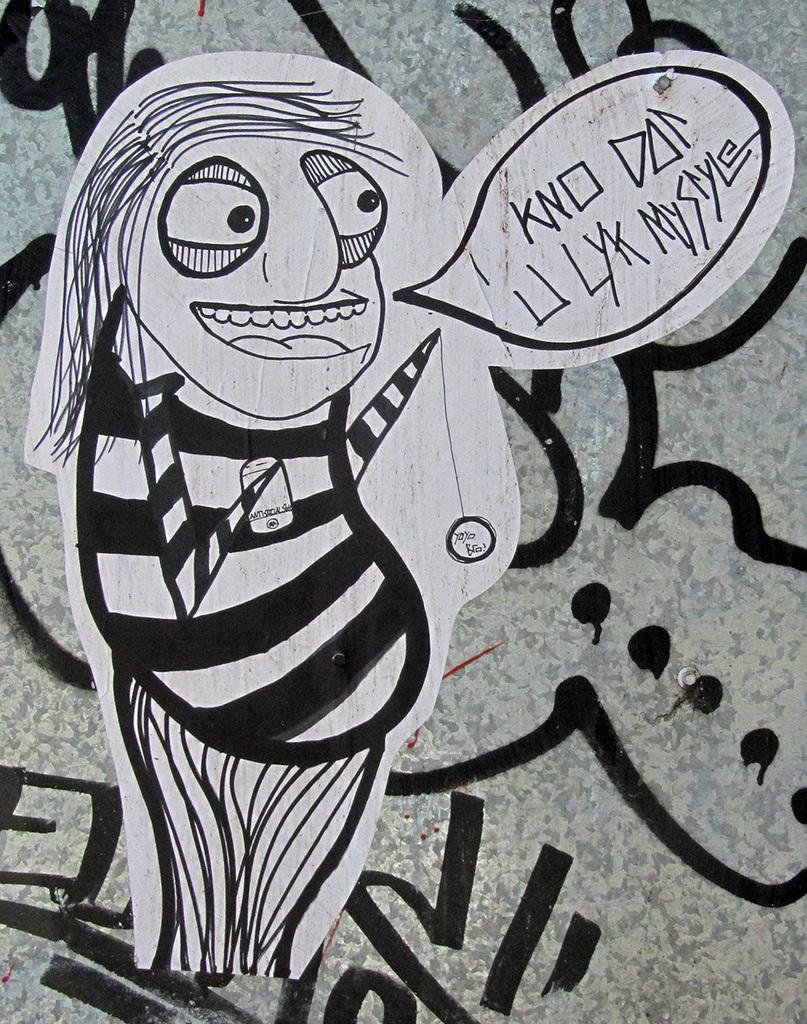What is depicted on the paper in the image? There is a picture drawn on a paper in the image. Where is the paper with the picture located? The paper with the picture is pasted on a wall. What else can be seen on the wall in the image? There are paintings on a wall in the image. How many icicles are hanging from the wall in the image? There are no icicles present in the image. What is the income of the artist who created the paintings on the wall? The income of the artist cannot be determined from the image. 